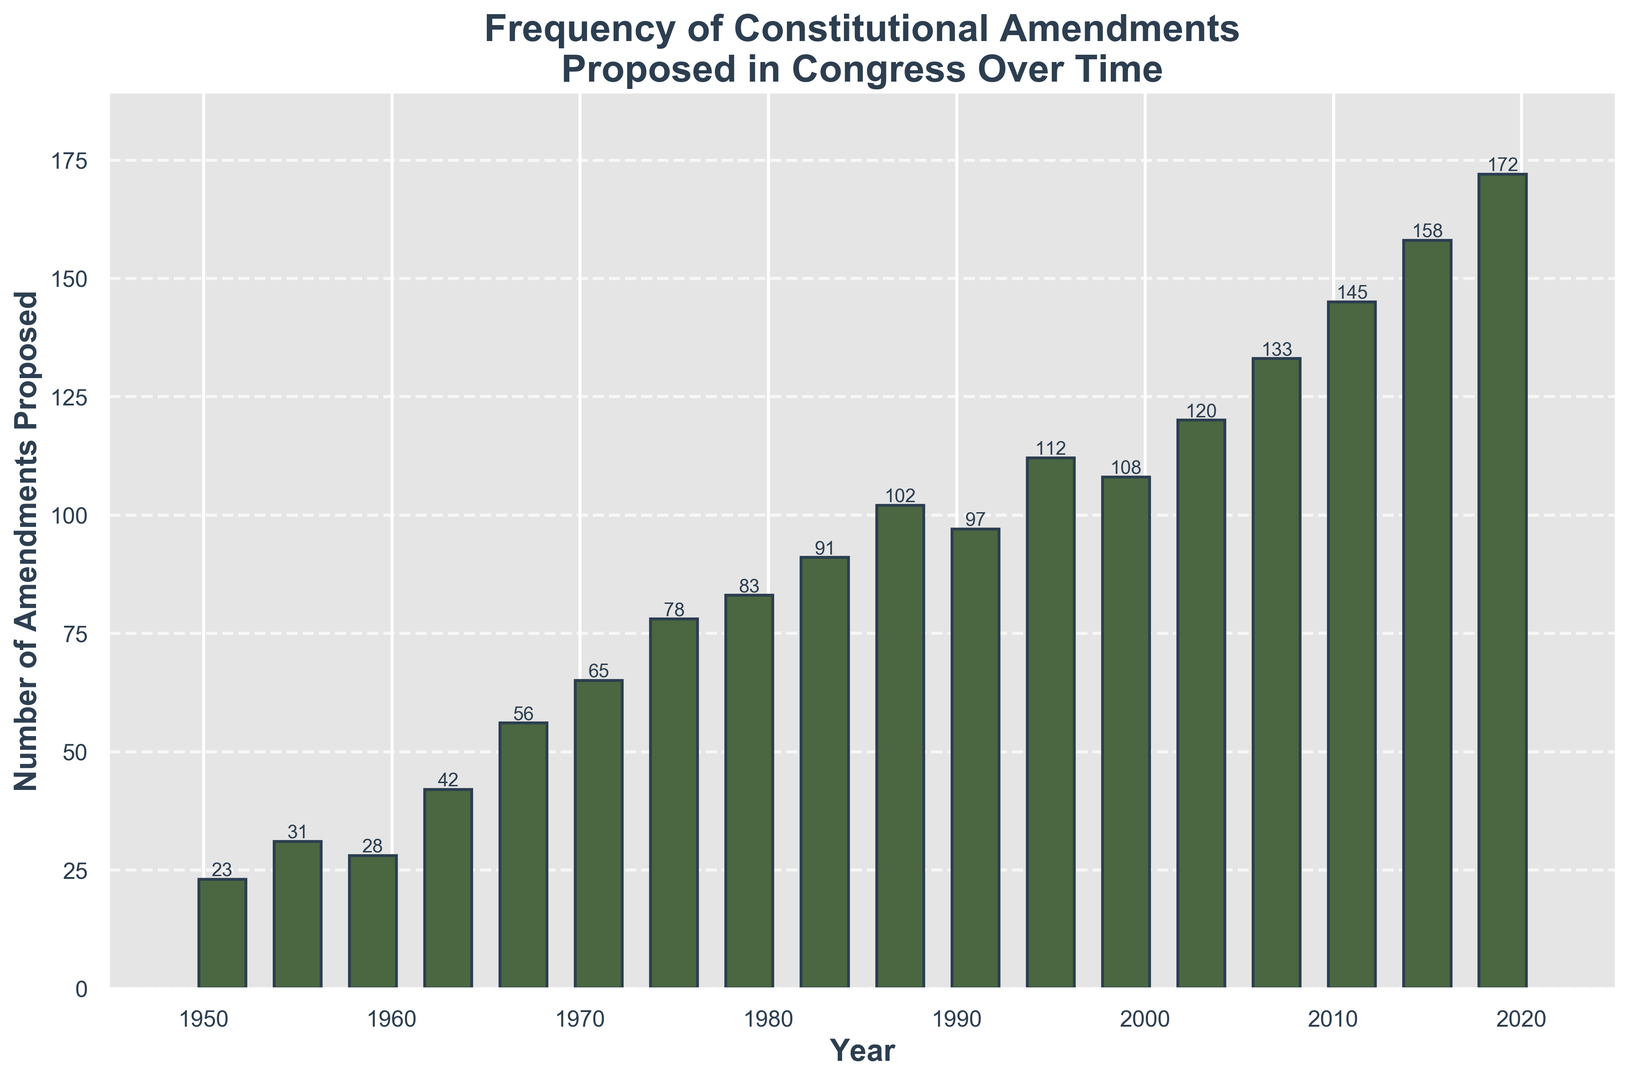Which year saw the highest number of constitutional amendments proposed? The highest bar represents the year with the maximum amendments. By observing the heights, the year 2019 has the tallest bar.
Answer: 2019 What is the difference in the number of amendments proposed between the years 1955 and 1963? The height of the bars for 1955 and 1963 shows the values 31 and 42, respectively. Subtract 31 from 42 to get the difference.
Answer: 11 During which year(s) did the number of proposed amendments exceed 100 for the first time? Identify the first year where the bar height surpasses the 100 mark. The year 1987 has the first bar that exceeds 100.
Answer: 1987 Calculate the average number of amendments proposed per year from 1951 to 2019. Sum up all the values of amendments from the start to the end and then divide by the number of years: (23+31+28+42+56+65+78+83+91+102+97+112+108+120+133+145+158+172)/18.
Answer: 88.6 How many years recorded amendments proposed greater than 150? List the bars taller than 150, corresponding to the years 2011, 2015, and 2019, and count them.
Answer: 3 Compare the number of amendments proposed in 1983 to those in 1991. Which year had more? Look at the bar heights for 1983 and 1991, showing values of 91 and 97, respectively. 1991 is higher than 1983.
Answer: 1991 From the data given, in which decade did Congress see the steepest increase in the number of amendments proposed? Compare the increments between each decade's starting and ending years. The increase from 1955 with 31 to 1967 with 56 shows a 25 increment, while from 2007's 133 to 2019's 172 gives the highest range difference of 39.
Answer: 2010s What can be said about the trend in the number of constitutional amendments proposed over time? By observing the overall increase in bar heights from left to right, the trend significantly shows an increasing pattern.
Answer: Increasing Which year saw a similar number of amendments proposed as 1975? Compare the height of the bars to 1975's height of 78 and find the closest matching values. The year 1959 nearly matches with an amendment value of 28, significantly less so the next closest is 1979 with 83.
Answer: 1979 Determine the sum of amendments proposed for the years 1999, 2003, and 2007. Add the values from those specific years: 108 + 120 + 133.
Answer: 361 